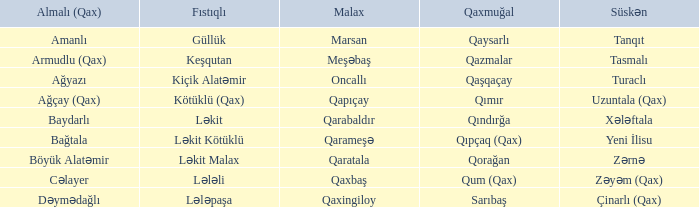Can you explain the qaxmuğal village that has a fistiqli village keşqutan? Qazmalar. 